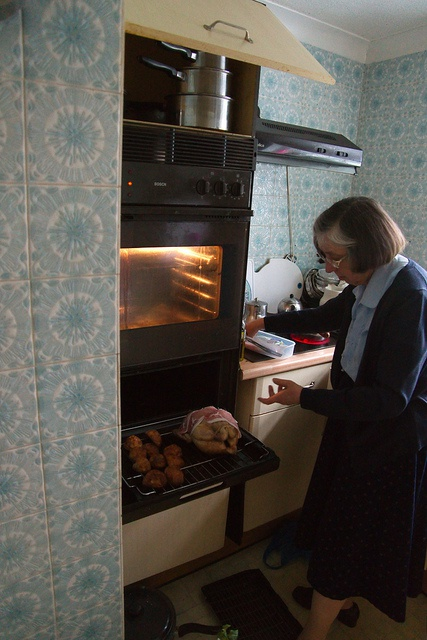Describe the objects in this image and their specific colors. I can see people in black, gray, maroon, and darkgray tones, oven in black, maroon, and gray tones, and oven in black, maroon, and gray tones in this image. 